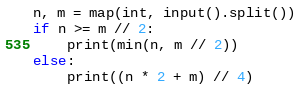Convert code to text. <code><loc_0><loc_0><loc_500><loc_500><_Python_>n, m = map(int, input().split())
if n >= m // 2:
    print(min(n, m // 2))
else:
    print((n * 2 + m) // 4)
</code> 